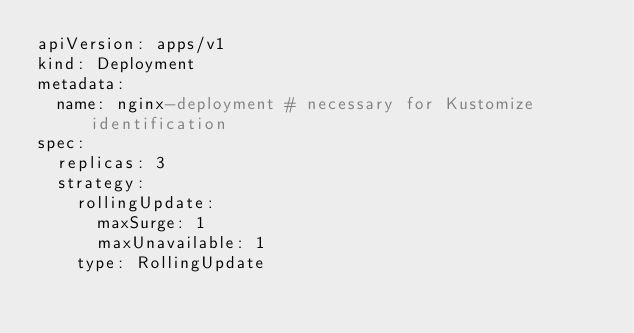<code> <loc_0><loc_0><loc_500><loc_500><_YAML_>apiVersion: apps/v1
kind: Deployment
metadata:
  name: nginx-deployment # necessary for Kustomize identification
spec:
  replicas: 3
  strategy:
    rollingUpdate:
      maxSurge: 1
      maxUnavailable: 1
    type: RollingUpdate
</code> 